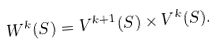<formula> <loc_0><loc_0><loc_500><loc_500>W ^ { k } ( S ) = V ^ { k + 1 } ( S ) \times V ^ { k } ( S ) .</formula> 